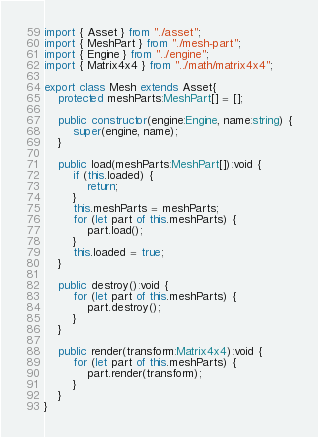<code> <loc_0><loc_0><loc_500><loc_500><_TypeScript_>import { Asset } from "./asset";
import { MeshPart } from "./mesh-part";
import { Engine } from "../engine";
import { Matrix4x4 } from "../math/matrix4x4";

export class Mesh extends Asset{
	protected meshParts:MeshPart[] = [];

	public constructor(engine:Engine, name:string) {
		super(engine, name);
	}

	public load(meshParts:MeshPart[]):void {
		if (this.loaded) {
			return;
		}
		this.meshParts = meshParts;
		for (let part of this.meshParts) {
			part.load();
		}
		this.loaded = true;
	}

	public destroy():void {
		for (let part of this.meshParts) {
			part.destroy();
		}
	}

	public render(transform:Matrix4x4):void {
		for (let part of this.meshParts) {
			part.render(transform);
		}
	}
}</code> 